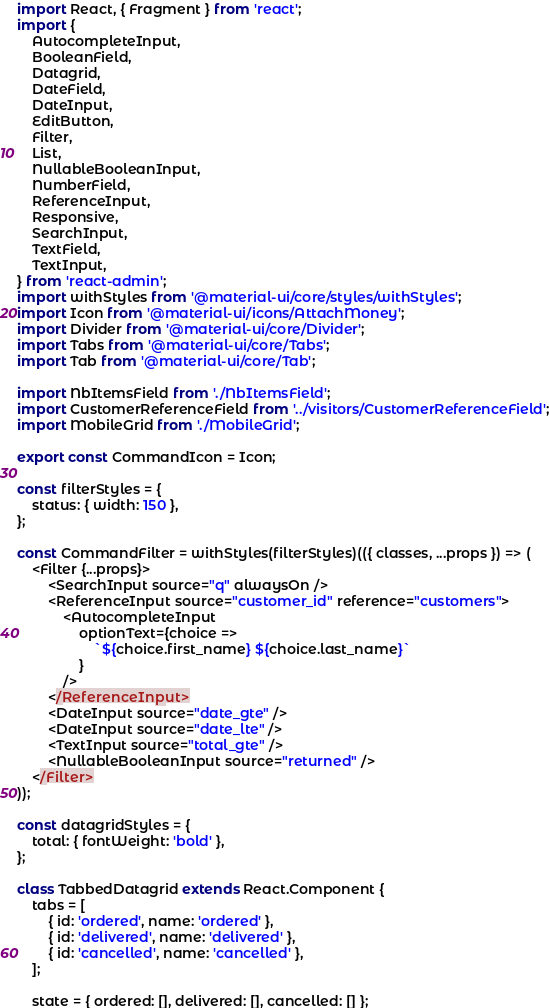Convert code to text. <code><loc_0><loc_0><loc_500><loc_500><_JavaScript_>import React, { Fragment } from 'react';
import {
    AutocompleteInput,
    BooleanField,
    Datagrid,
    DateField,
    DateInput,
    EditButton,
    Filter,
    List,
    NullableBooleanInput,
    NumberField,
    ReferenceInput,
    Responsive,
    SearchInput,
    TextField,
    TextInput,
} from 'react-admin';
import withStyles from '@material-ui/core/styles/withStyles';
import Icon from '@material-ui/icons/AttachMoney';
import Divider from '@material-ui/core/Divider';
import Tabs from '@material-ui/core/Tabs';
import Tab from '@material-ui/core/Tab';

import NbItemsField from './NbItemsField';
import CustomerReferenceField from '../visitors/CustomerReferenceField';
import MobileGrid from './MobileGrid';

export const CommandIcon = Icon;

const filterStyles = {
    status: { width: 150 },
};

const CommandFilter = withStyles(filterStyles)(({ classes, ...props }) => (
    <Filter {...props}>
        <SearchInput source="q" alwaysOn />
        <ReferenceInput source="customer_id" reference="customers">
            <AutocompleteInput
                optionText={choice =>
                    `${choice.first_name} ${choice.last_name}`
                }
            />
        </ReferenceInput>
        <DateInput source="date_gte" />
        <DateInput source="date_lte" />
        <TextInput source="total_gte" />
        <NullableBooleanInput source="returned" />
    </Filter>
));

const datagridStyles = {
    total: { fontWeight: 'bold' },
};

class TabbedDatagrid extends React.Component {
    tabs = [
        { id: 'ordered', name: 'ordered' },
        { id: 'delivered', name: 'delivered' },
        { id: 'cancelled', name: 'cancelled' },
    ];

    state = { ordered: [], delivered: [], cancelled: [] };
</code> 